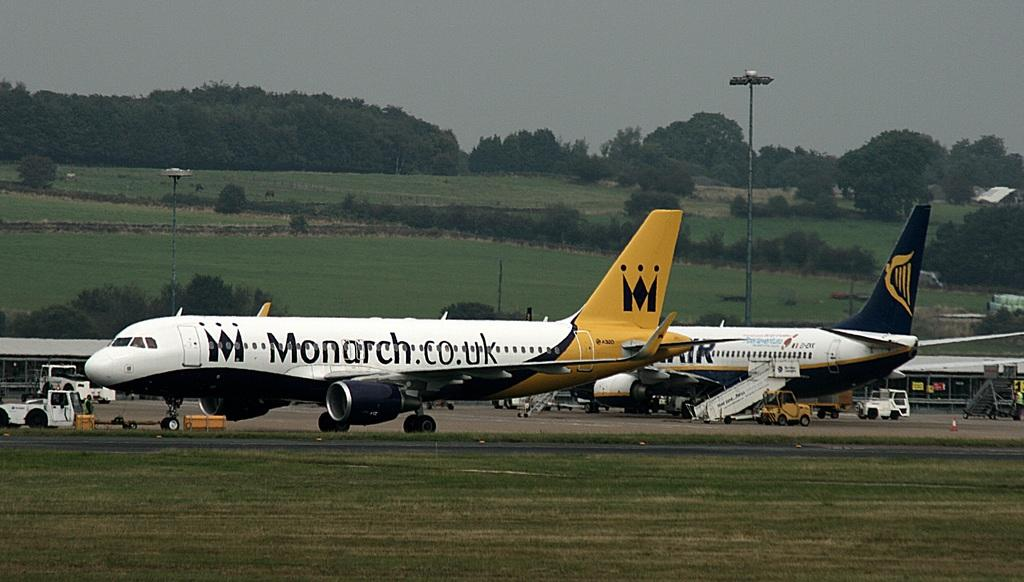<image>
Share a concise interpretation of the image provided. a Monarch.co.uk plane is at an airport with another plane 